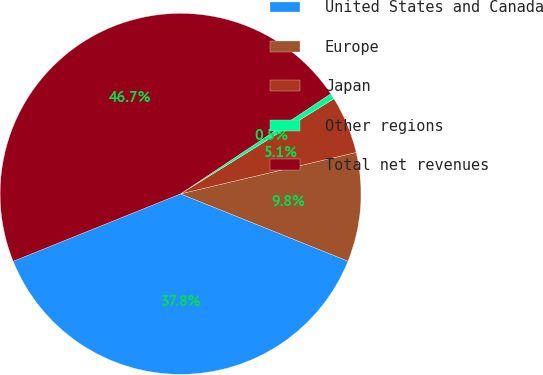Convert chart to OTSL. <chart><loc_0><loc_0><loc_500><loc_500><pie_chart><fcel>United States and Canada<fcel>Europe<fcel>Japan<fcel>Other regions<fcel>Total net revenues<nl><fcel>37.83%<fcel>9.77%<fcel>5.15%<fcel>0.52%<fcel>46.74%<nl></chart> 